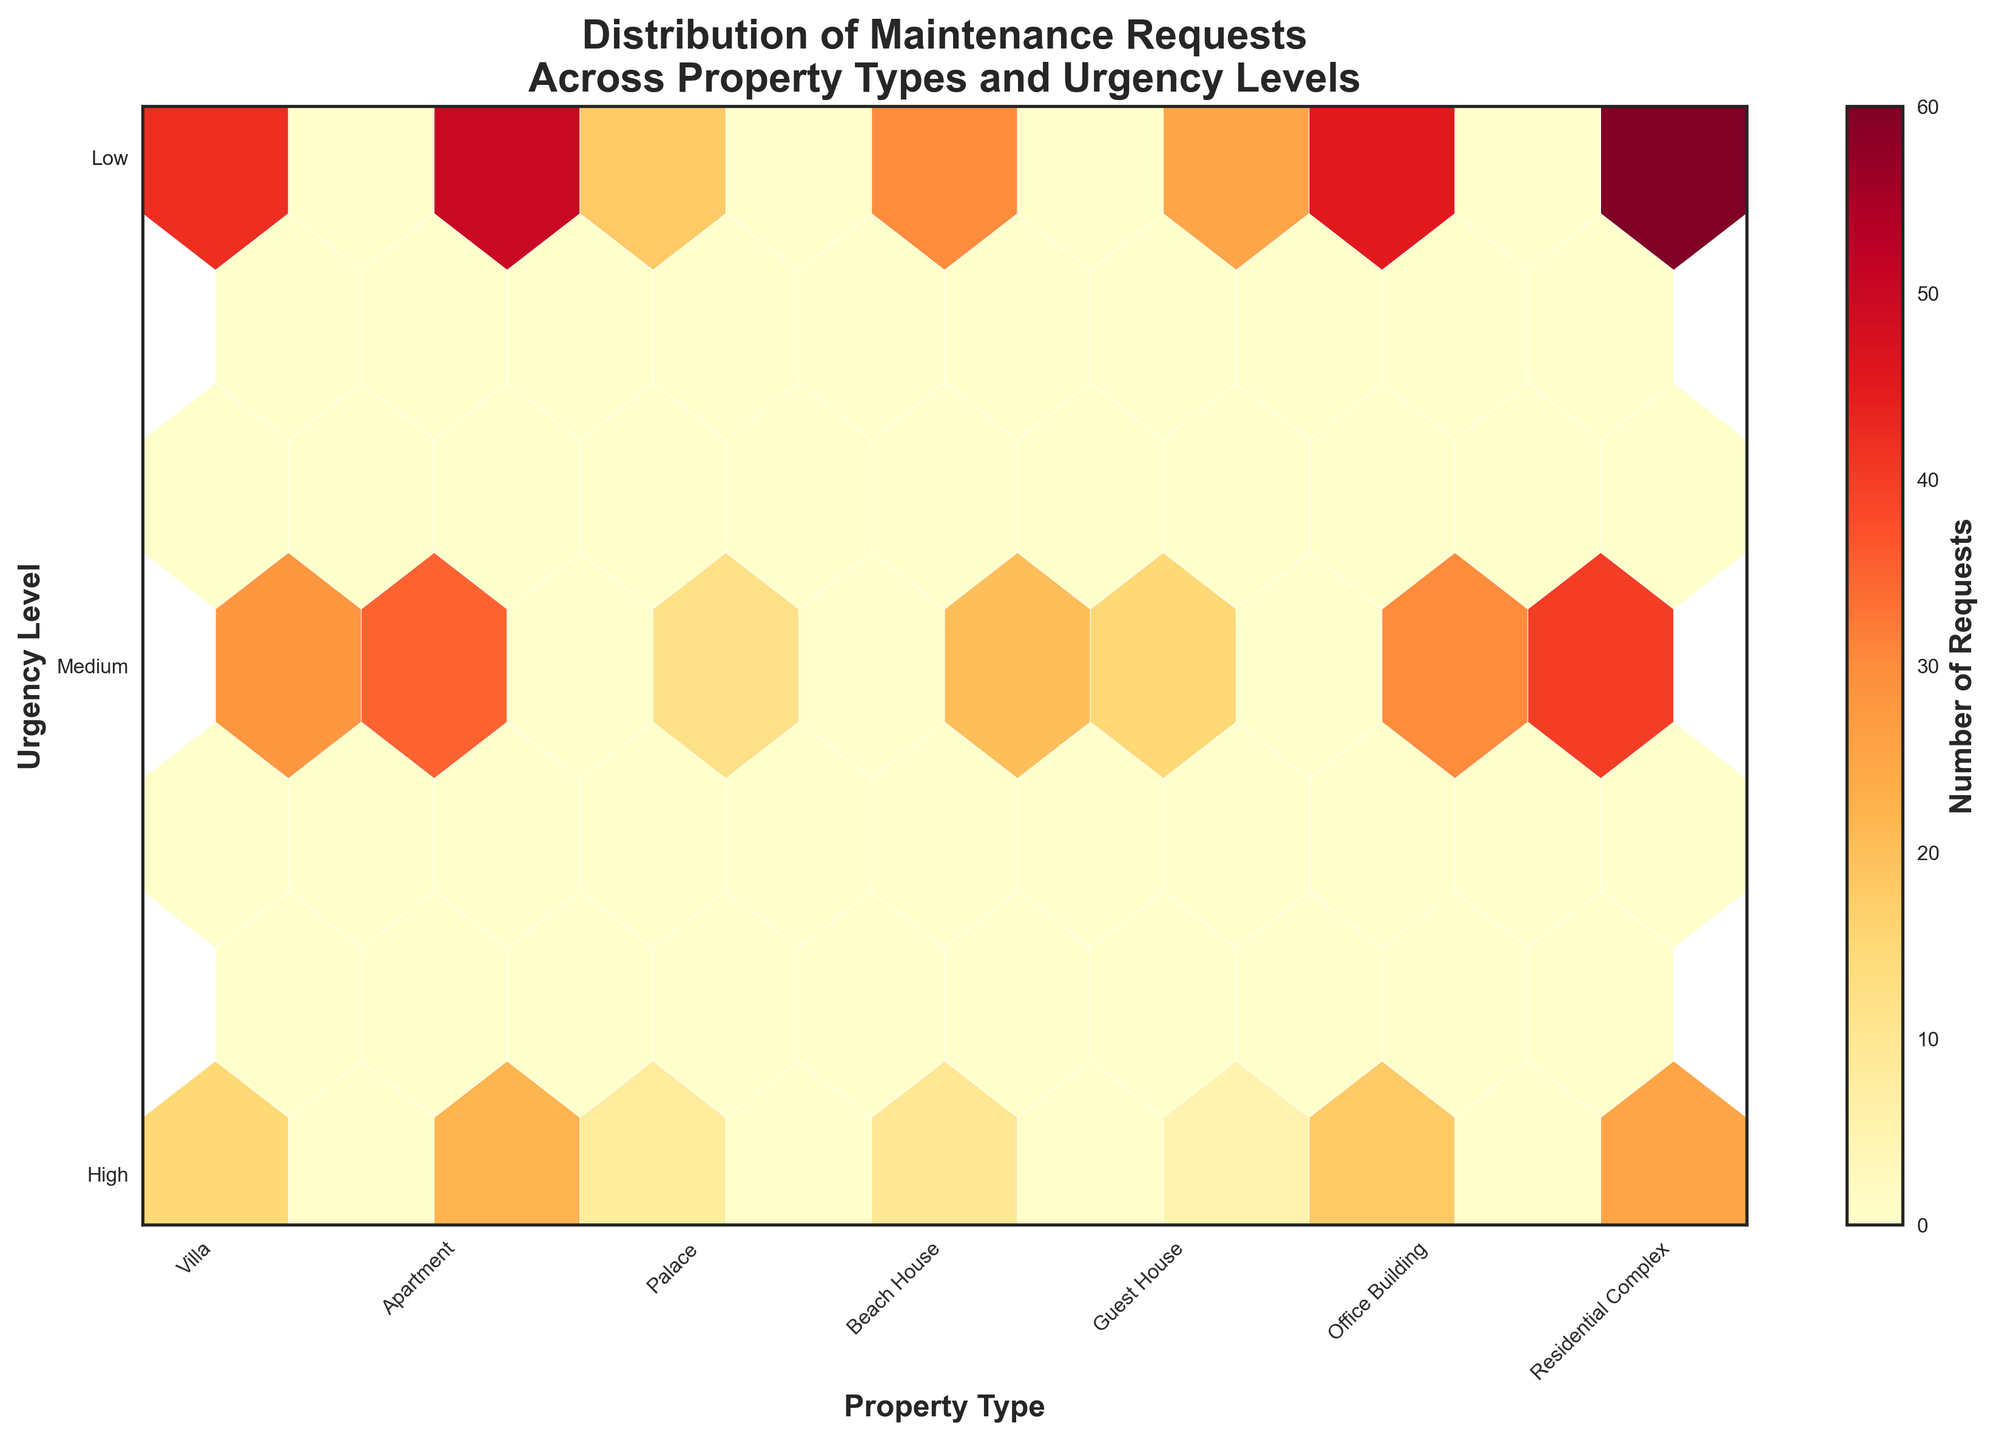What's the title of the figure? The title is usually displayed at the top of the plot. In this case, it is clearly mentioned at the top.
Answer: Distribution of Maintenance Requests Across Property Types and Urgency Levels What does the x-axis represent? The x-axis is labeled at the bottom of the plot. It represents the different types of properties.
Answer: Property Type What does the y-axis represent? The y-axis is labeled on the side of the plot. It represents the urgency levels of the requests.
Answer: Urgency Level Which property type has the highest number of high-urgency maintenance requests? By looking at the density and color of the hexagons along the "High" urgency level, we identify the property type with the most concentrated and darkest hexagon.
Answer: Residential Complex Which urgency level has the most maintenance requests overall? We compare the density and color of hexagons across all property types for each urgency level. The level with consistently darker hexagons indicates the highest number of requests.
Answer: Low For the property type 'Villa,' which urgency level has the most maintenance requests? By identifying the hexagons corresponding to 'Villa' on the x-axis, we check which urgency level has the darkest hexagon.
Answer: Low Which property type has the least number of high-urgency maintenance requests? By comparing the density and color of the hexagons along the "High" urgency level, we find the property type with the lightest hexagon.
Answer: Guest House How does the distribution of medium-urgency requests compare between 'Apartment' and 'Office Building'? By comparing the density and color of hexagons at the "Medium" urgency level for both 'Apartment' and 'Office Building', we determine which one has darker hexagons.
Answer: Office Building has more medium-urgency requests What's the combined number of low-urgency maintenance requests for 'Villa' and 'Beach House'? Sum the numbers of requests from the provided data: 'Villa' has 42 and 'Beach House' has 30 low-urgency requests.
Answer: 72 Which property type(s) have a high concentration of requests across all urgency levels? Analyze the plot for property types with consistently dark hexagons across high, medium, and low urgency levels.
Answer: Residential Complex 